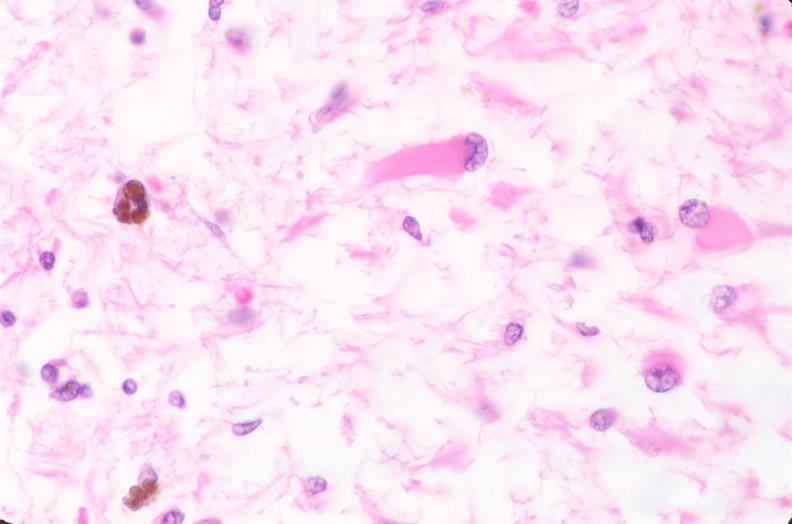what is present?
Answer the question using a single word or phrase. Nervous 